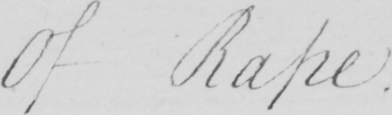Please transcribe the handwritten text in this image. Of Rape 